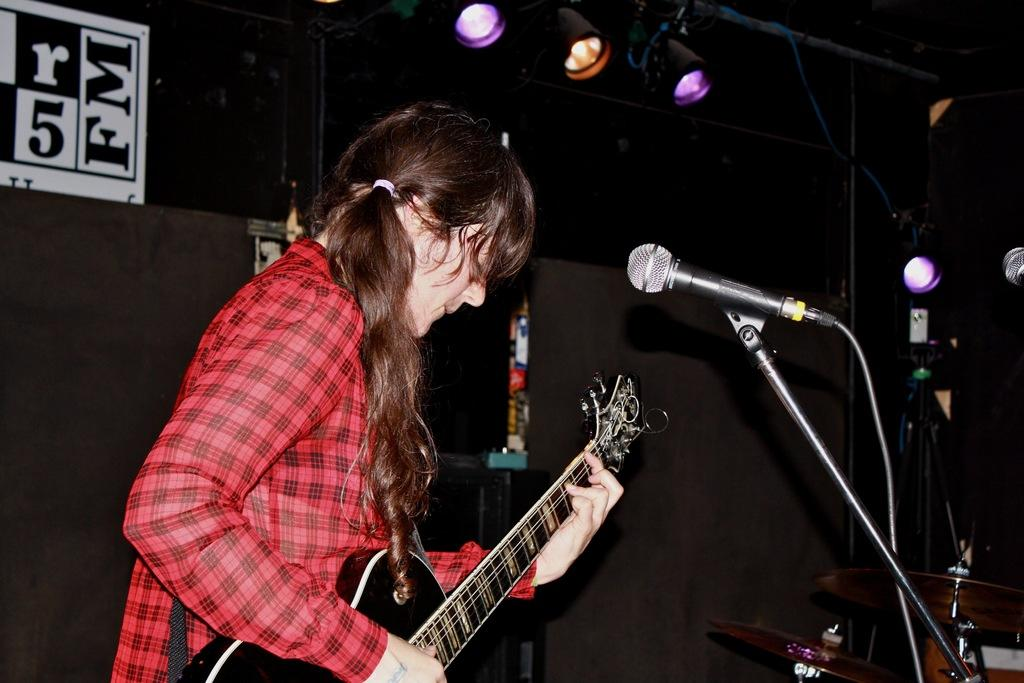What is the man in the image doing? The man is playing the guitar in the image. What instrument is the man holding? The man is holding a guitar. What object is present for amplifying sound? There is a microphone in the image. What is used to support the guitar? There is a stand in the image. What can be seen in the background of the image? There are lights and a wall in the background of the image. How many cacti are visible in the image? There are no cacti present in the image. What direction is the sun shining from in the image? The image does not show the sun, so it cannot be determined from which direction the sun is shining. 